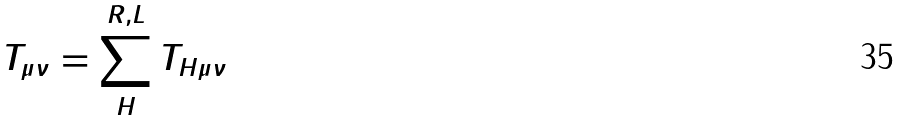Convert formula to latex. <formula><loc_0><loc_0><loc_500><loc_500>T _ { \mu \nu } = \sum _ { H } ^ { R , L } T _ { H \mu \nu }</formula> 